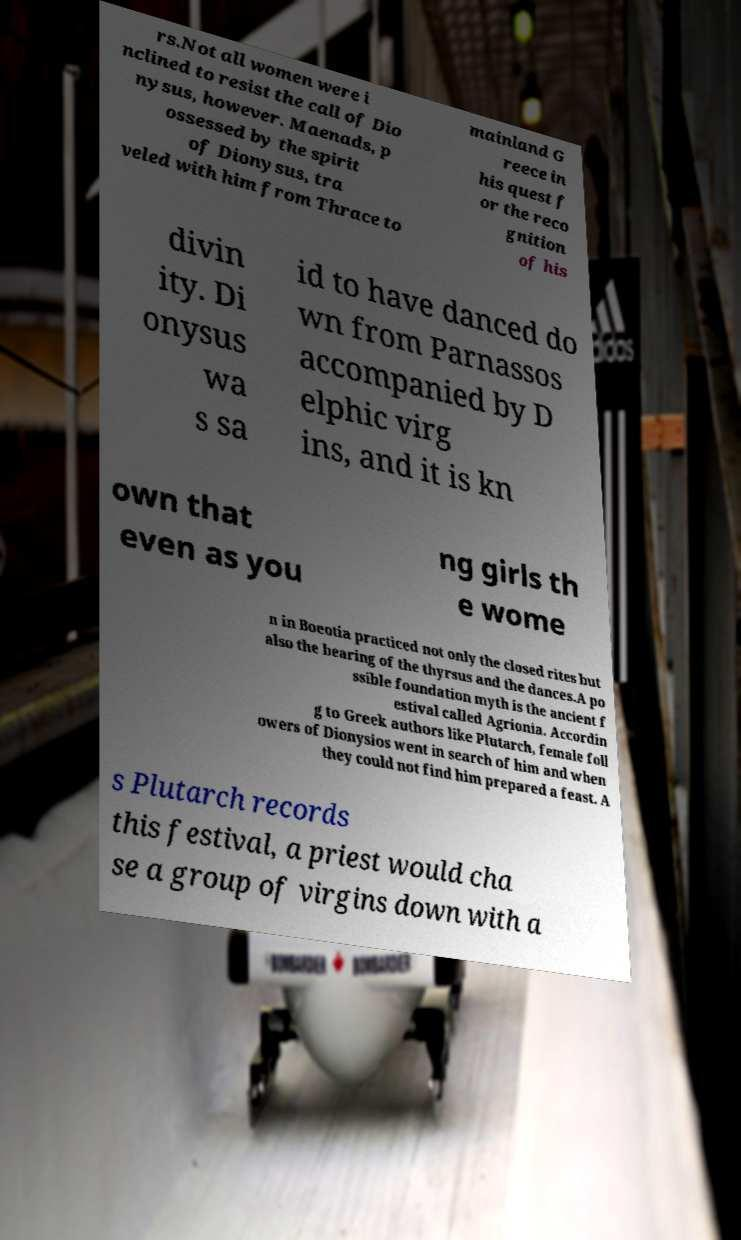Please read and relay the text visible in this image. What does it say? rs.Not all women were i nclined to resist the call of Dio nysus, however. Maenads, p ossessed by the spirit of Dionysus, tra veled with him from Thrace to mainland G reece in his quest f or the reco gnition of his divin ity. Di onysus wa s sa id to have danced do wn from Parnassos accompanied by D elphic virg ins, and it is kn own that even as you ng girls th e wome n in Boeotia practiced not only the closed rites but also the bearing of the thyrsus and the dances.A po ssible foundation myth is the ancient f estival called Agrionia. Accordin g to Greek authors like Plutarch, female foll owers of Dionysios went in search of him and when they could not find him prepared a feast. A s Plutarch records this festival, a priest would cha se a group of virgins down with a 